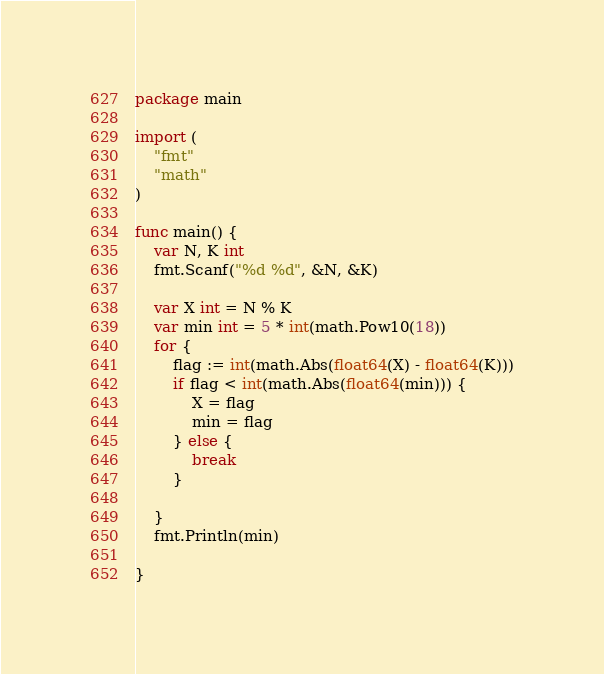<code> <loc_0><loc_0><loc_500><loc_500><_Go_>package main

import (
	"fmt"
	"math"
)

func main() {
	var N, K int
	fmt.Scanf("%d %d", &N, &K)

	var X int = N % K
	var min int = 5 * int(math.Pow10(18))
	for {
		flag := int(math.Abs(float64(X) - float64(K)))
		if flag < int(math.Abs(float64(min))) {
			X = flag
			min = flag
		} else {
			break
		}

	}
	fmt.Println(min)

}
</code> 